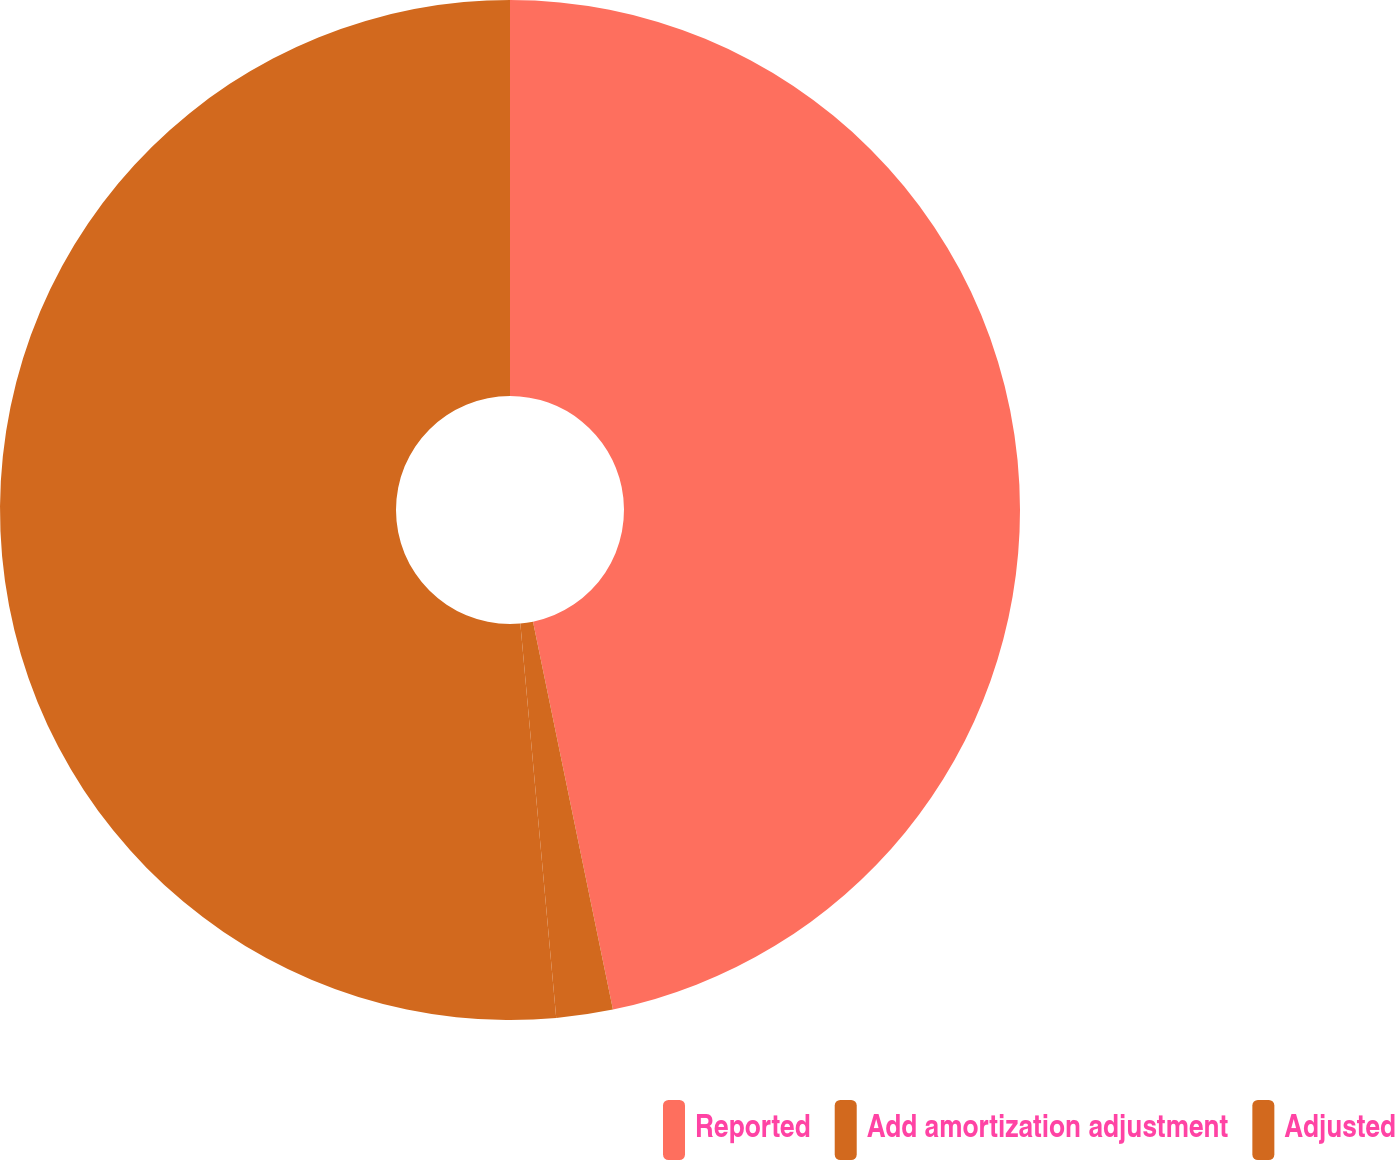<chart> <loc_0><loc_0><loc_500><loc_500><pie_chart><fcel>Reported<fcel>Add amortization adjustment<fcel>Adjusted<nl><fcel>46.77%<fcel>1.79%<fcel>51.45%<nl></chart> 